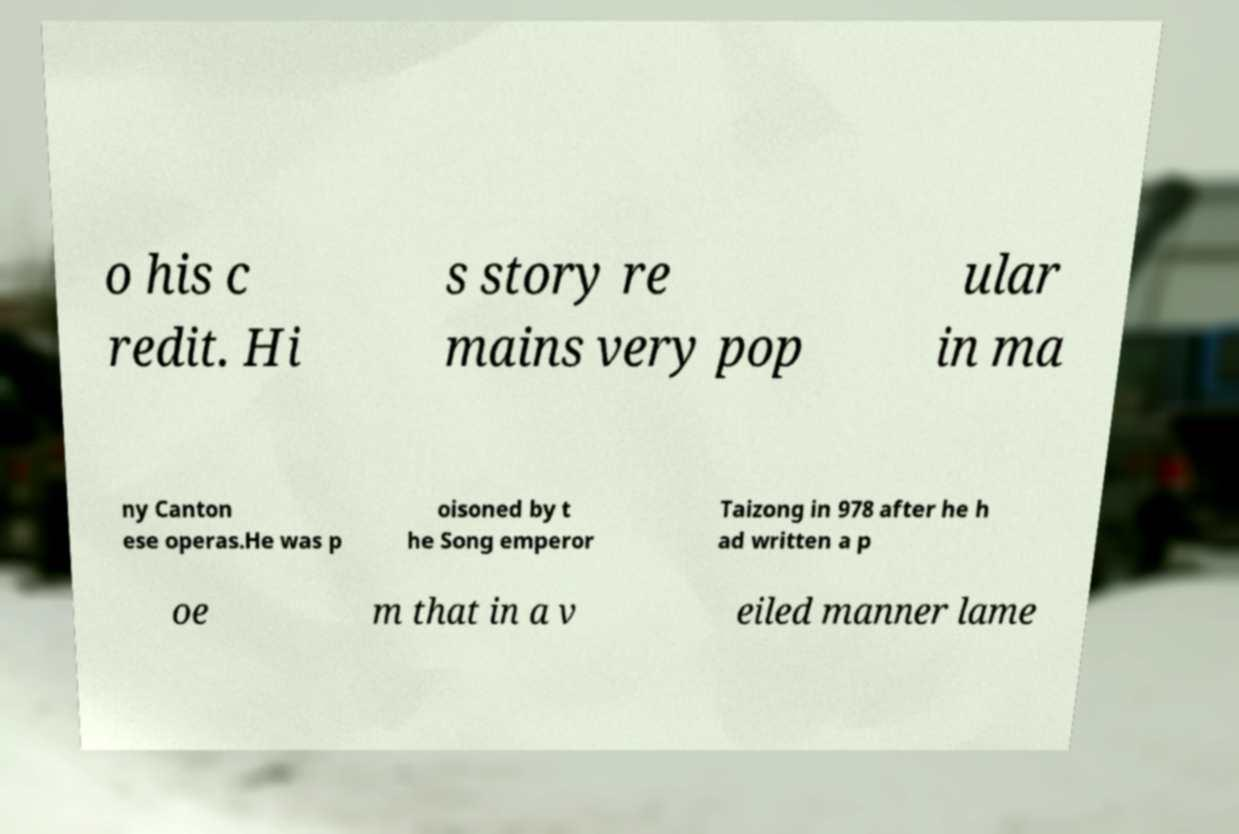Can you read and provide the text displayed in the image?This photo seems to have some interesting text. Can you extract and type it out for me? o his c redit. Hi s story re mains very pop ular in ma ny Canton ese operas.He was p oisoned by t he Song emperor Taizong in 978 after he h ad written a p oe m that in a v eiled manner lame 